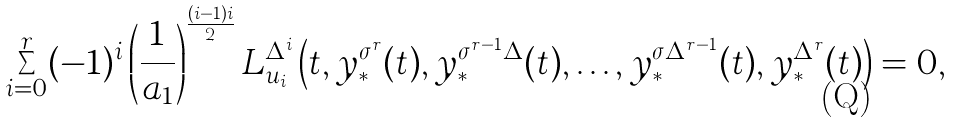Convert formula to latex. <formula><loc_0><loc_0><loc_500><loc_500>\sum _ { i = 0 } ^ { r } ( - 1 ) ^ { i } \left ( \frac { 1 } { a _ { 1 } } \right ) ^ { \frac { ( i - 1 ) i } { 2 } } L ^ { \Delta ^ { i } } _ { u _ { i } } \left ( t , y _ { \ast } ^ { \sigma ^ { r } } ( t ) , y _ { \ast } ^ { \sigma ^ { r - 1 } \Delta } ( t ) , \dots , y _ { \ast } ^ { \sigma \Delta ^ { r - 1 } } ( t ) , y _ { \ast } ^ { \Delta ^ { r } } ( t ) \right ) = 0 ,</formula> 